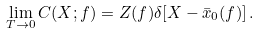Convert formula to latex. <formula><loc_0><loc_0><loc_500><loc_500>\lim _ { T \to 0 } C ( X ; f ) = Z ( f ) \delta [ X - \bar { x } _ { 0 } ( f ) ] \, .</formula> 